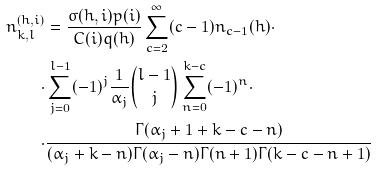<formula> <loc_0><loc_0><loc_500><loc_500>n ^ { ( h , i ) } _ { k , l } & = \frac { \sigma ( h , i ) p ( i ) } { C ( i ) q ( h ) } \sum _ { c = 2 } ^ { \infty } ( c - 1 ) n _ { c - 1 } ( h ) \cdot \\ \cdot & \sum _ { j = 0 } ^ { l - 1 } ( - 1 ) ^ { j } \frac { 1 } { \alpha _ { j } } { l - 1 \choose j } \sum _ { n = 0 } ^ { k - c } ( - 1 ) ^ { n } \cdot \\ \cdot & \frac { \Gamma ( \alpha _ { j } + 1 + k - c - n ) } { ( \alpha _ { j } + k - n ) \Gamma ( \alpha _ { j } - n ) \Gamma ( n + 1 ) \Gamma ( k - c - n + 1 ) }</formula> 